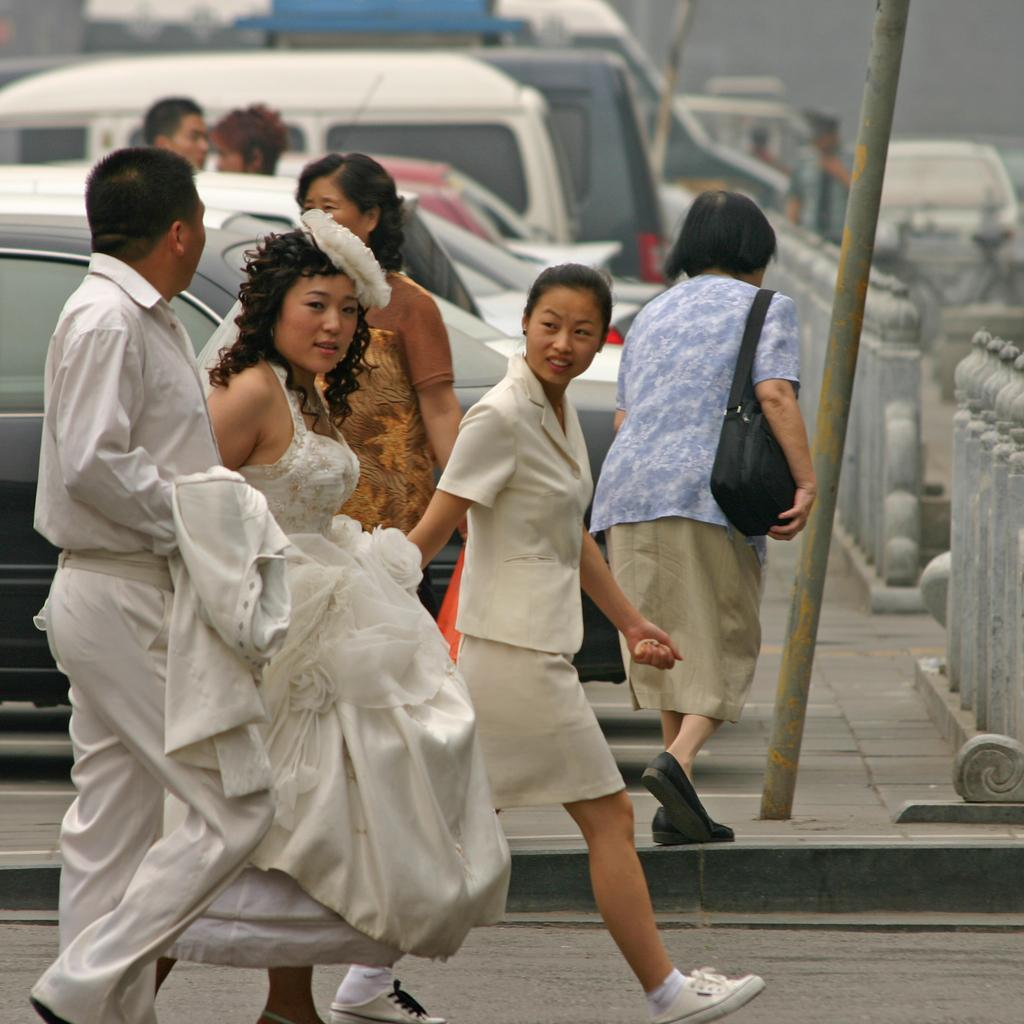Who or what can be seen in the image? There are people in the image. What is the tall, vertical object in the image? There is a pole in the image. What else is present in the image besides people? There are vehicles and fencing in the image. What are the people in the image doing? The people are walking. What type of riddle can be solved using the calculator in the image? There is no calculator present in the image, so it cannot be used to solve any riddles. 